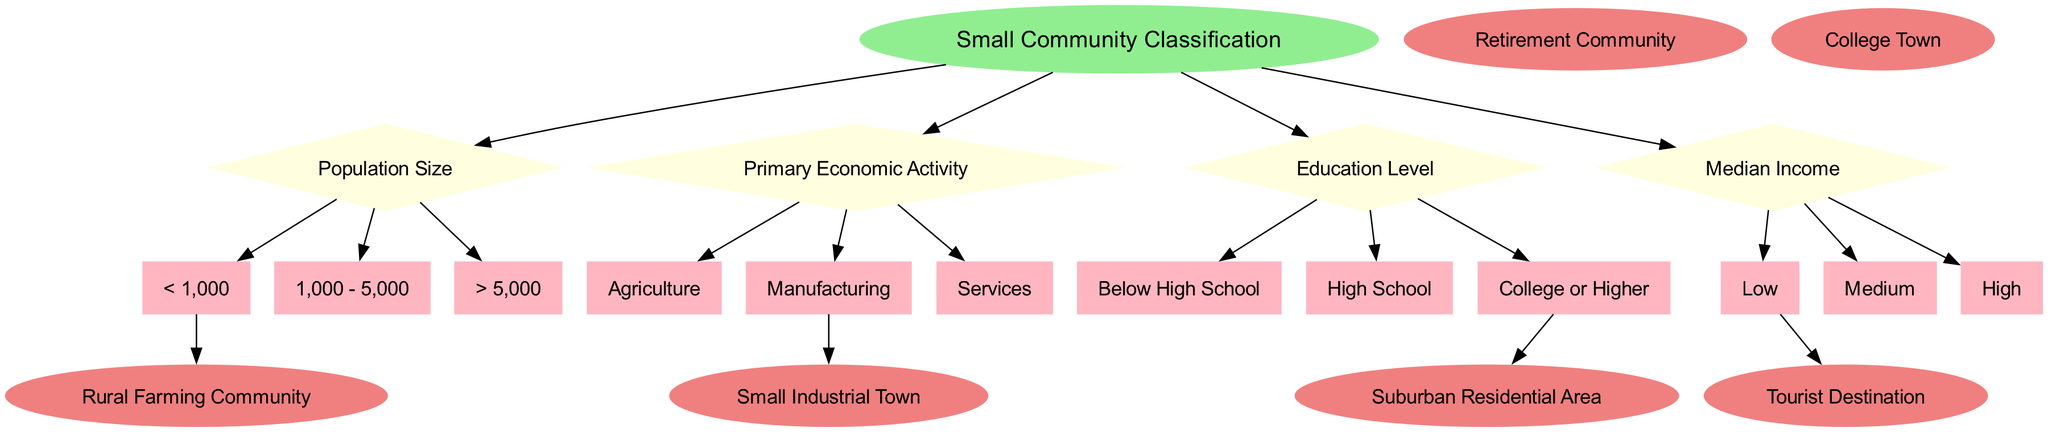What is the root node in the diagram? The root node is the first node in the diagram, which represents the main topic of classification. In this case, the root node is "Small Community Classification."
Answer: Small Community Classification How many decision nodes are present in the diagram? The diagram contains four decision nodes, each representing different criteria for classifying small communities.
Answer: 4 What are the children of the "Population Size" decision node? The children of the "Population Size" decision node represent different population categories: "< 1,000", "1,000 - 5,000", and "> 5,000".
Answer: < 1,000, 1,000 - 5,000, > 5,000 Which leaf node is connected to the first child of the "Primary Economic Activity"? To find the connected leaf node, we need to follow the edges. The first child of "Primary Economic Activity" is "Agriculture," which connects to "Rural Farming Community."
Answer: Rural Farming Community If a community has a high median income and is primarily service-based, what classification can it receive? First, the decision node related to "Median Income" will classify it as "High," and then the "Primary Economic Activity" as "Services." In this context, a suitable classification would likely be "Suburban Residential Area."
Answer: Suburban Residential Area Which two decision nodes are connected to the leaf node "College Town"? To determine this, we analyze the connections in the diagram. "College Town" is connected to the decision nodes for "Population Size" and "Education Level."
Answer: Population Size, Education Level What is the significance of the shape used for the leaf nodes in the diagram? The leaf nodes are depicted as ellipses, indicating they are final classifications or outcomes in the decision-making process. This differentiates them from decision nodes, which are diamonds.
Answer: Final classifications How many leaf nodes are there in total? The total number of leaf nodes indicates the various classifications possible based on the decision tree. In this diagram, there are six leaf nodes.
Answer: 6 